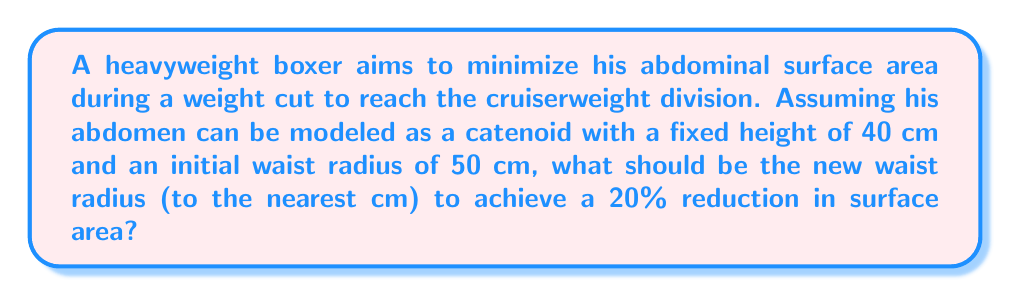Could you help me with this problem? Let's approach this step-by-step:

1) The surface area of a catenoid is given by the formula:

   $$A = 2\pi c^2 \left(\cosh\left(\frac{h}{2c}\right) - 1\right)$$

   where $c$ is the catenary constant, and $h$ is the height.

2) We need to find the catenary constant $c$ for the initial state. The relationship between the waist radius $r$ and height $h$ is:

   $$r = c \cosh\left(\frac{h}{2c}\right)$$

3) Given $r = 50$ cm and $h = 40$ cm, we can solve for $c$:

   $$50 = c \cosh\left(\frac{40}{2c}\right)$$

   Solving this numerically, we get $c \approx 33.33$ cm.

4) Now we can calculate the initial surface area:

   $$A_1 = 2\pi (33.33)^2 \left(\cosh\left(\frac{40}{2(33.33)}\right) - 1\right) \approx 13,351 \text{ cm}^2$$

5) We want to reduce this by 20%, so the new surface area should be:

   $$A_2 = 0.8 \times 13,351 \approx 10,681 \text{ cm}^2$$

6) Now we need to find the new radius $r_2$ that gives this surface area. We can use the same formulas, but now we're solving for $r_2$ given $A_2$ and $h$:

   $$10,681 = 2\pi c^2 \left(\cosh\left(\frac{40}{2c}\right) - 1\right)$$
   $$r_2 = c \cosh\left(\frac{40}{2c}\right)$$

7) Solving these equations numerically, we get:

   $$c \approx 29.85 \text{ cm}$$
   $$r_2 \approx 44.78 \text{ cm}$$

8) Rounding to the nearest cm, we get 45 cm.
Answer: 45 cm 